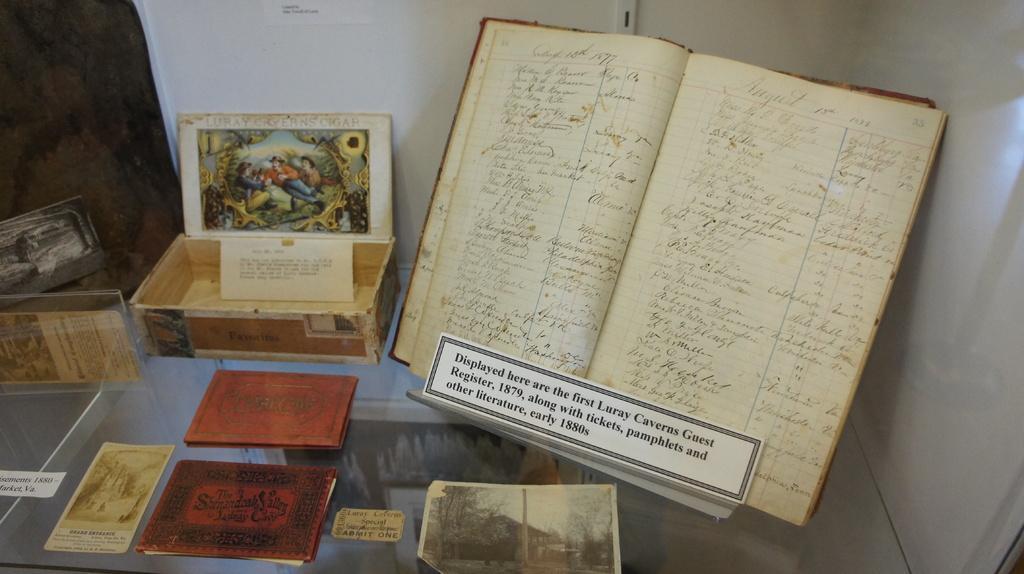Please provide a concise description of this image. There is a register book, box, papers and many other things on a surface. In the back there is a wall. 